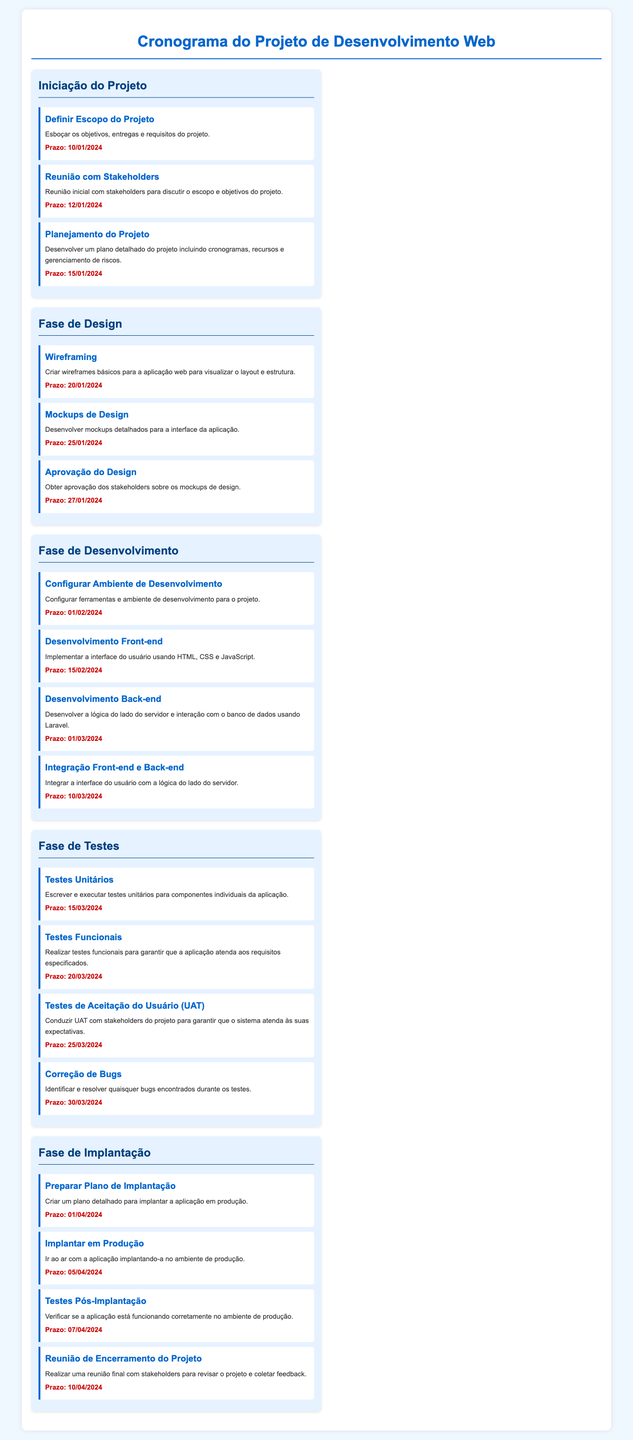Qual é a data de início do projeto? A data de início do projeto é encontrada nas tarefas da seção "Iniciação do Projeto".
Answer: 10/01/2024 Quantas fases estão listadas no cronograma? O cronograma possui cinco fases principais.
Answer: 5 Qual é a tarefa que deve ser concluída antes da "Implantar em Produção"? A tarefa que deve ser concluída antes da implantação é "Preparar Plano de Implantação".
Answer: Preparar Plano de Implantação Qual é o prazo para a "Correção de Bugs"? O prazo é informado na seção "Fase de Testes", específica para a tarefa "Correção de Bugs".
Answer: 30/03/2024 Quem é o responsável pela "Aprovação do Design"? O responsável pode ser inferido como os stakeholders mencionados na tarefa "Aprovação do Design".
Answer: Stakeholders Qual é a última tarefa listada no cronograma? A última tarefa é a "Reunião de Encerramento do Projeto".
Answer: Reunião de Encerramento do Projeto Quando são realizados os "Testes Funcionais"? A data para os "Testes Funcionais" é listada na seção "Fase de Testes".
Answer: 20/03/2024 Qual é a cor de fundo da seção de "Fase de Design"? O fundo da seção "Fase de Design" é de um tom claro, especificado como azul claro no documento.
Answer: Azul claro 